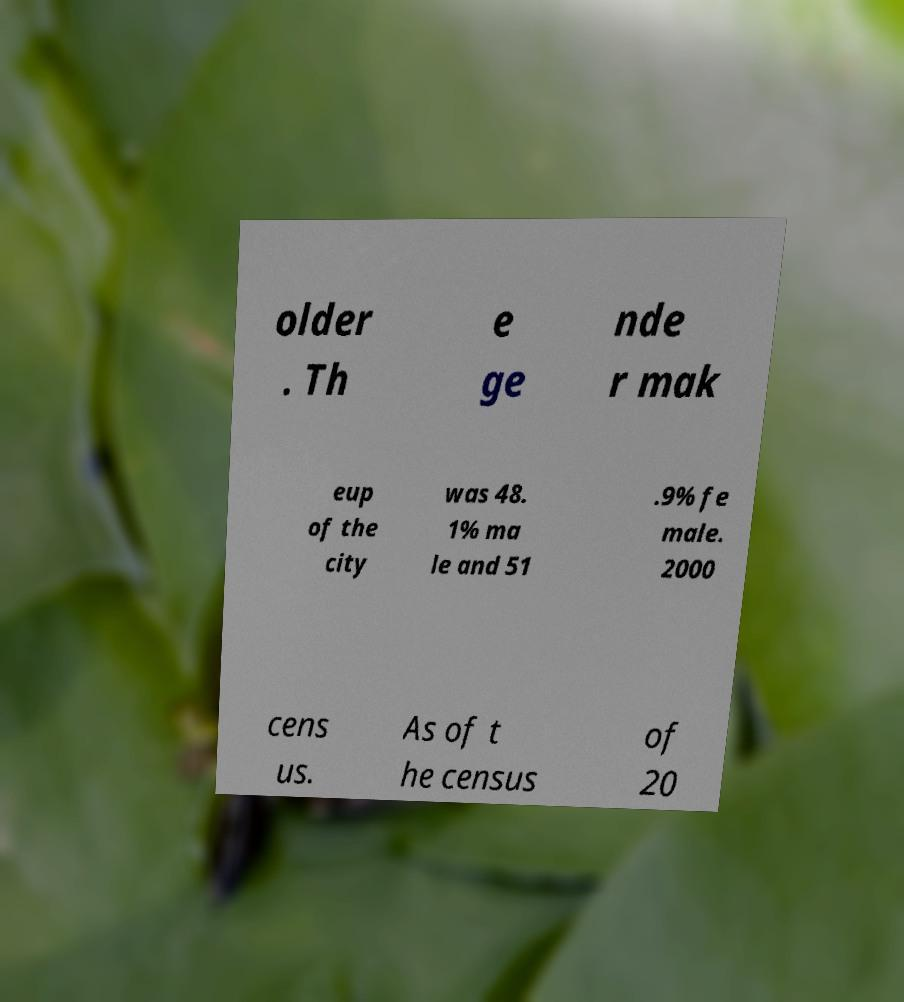There's text embedded in this image that I need extracted. Can you transcribe it verbatim? older . Th e ge nde r mak eup of the city was 48. 1% ma le and 51 .9% fe male. 2000 cens us. As of t he census of 20 